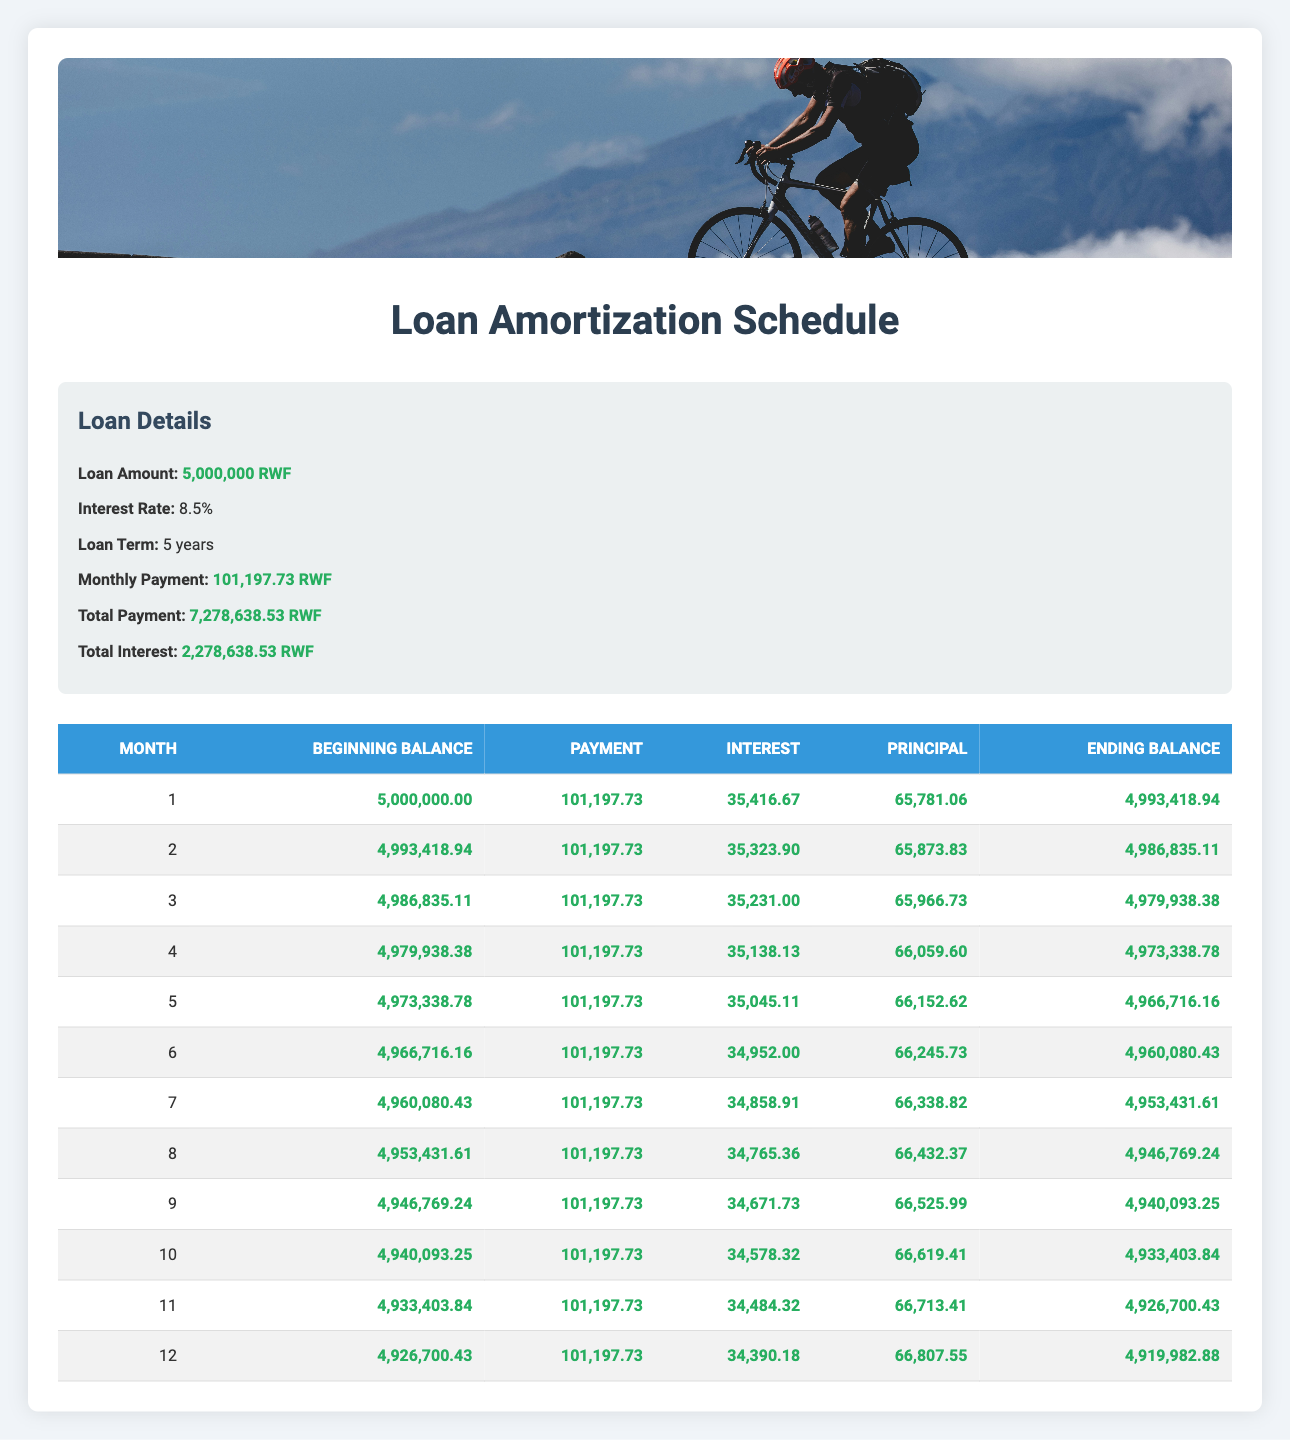What is the total interest paid over the loan term? The total interest is indicated in the loan details section of the table, which states that the total interest is 2,278,638.53 RWF.
Answer: 2,278,638.53 RWF What is the monthly payment amount? The monthly payment is also found in the loan details section where it is specified as 101,197.73 RWF.
Answer: 101,197.73 RWF During which month is the principal payment the highest? To find this, we look at the principal amounts in each row of the amortization schedule. The maximum value is 66,807.55 RWF in month 12.
Answer: Month 12 What is the average principal payment made during the first 6 months? We sum the principal payments made in the first six months: 65,781.06 + 65,873.83 + 65,966.73 + 66,059.60 + 66,152.62 + 66,245.73 = 400,079.57. Next, we divide by 6 to find the average: 400,079.57 / 6 = 66,680.0 RWF.
Answer: 66,680.0 RWF Is the total payment at the end of 5 years more than the loan amount? The total payment is recorded as 7,278,638.53 RWF, while the loan amount is 5,000,000 RWF. Since 7,278,638.53 RWF > 5,000,000 RWF, the answer is yes.
Answer: Yes How much is the ending balance after month 4? The ending balance after month 4 is noted in the amortization schedule where it shows 4,973,338.78 RWF at the end of month 4.
Answer: 4,973,338.78 RWF What is the difference in beginning balances between month 1 and month 3? The beginning balance in month 1 is 5,000,000 RWF and in month 3 it is 4,986,835.11 RWF. The difference is calculated as 5,000,000 - 4,986,835.11 = 13,164.89 RWF.
Answer: 13,164.89 RWF In the second month, how much interest is paid compared to the first month? From the amortization schedule, the interest in month 1 is 35,416.67 RWF and in month 2 it is 35,323.90 RWF. The comparison shows that month 2 has 92.77 RWF less interest paid than month 1.
Answer: 92.77 RWF less If the loan is paid off early after 10 months, what will the remaining balance be? By the end of month 10, the ending balance is 4,933,403.84 RWF according to the amortization schedule. Thus, if paid off after 10 months, this amount remains.
Answer: 4,933,403.84 RWF 